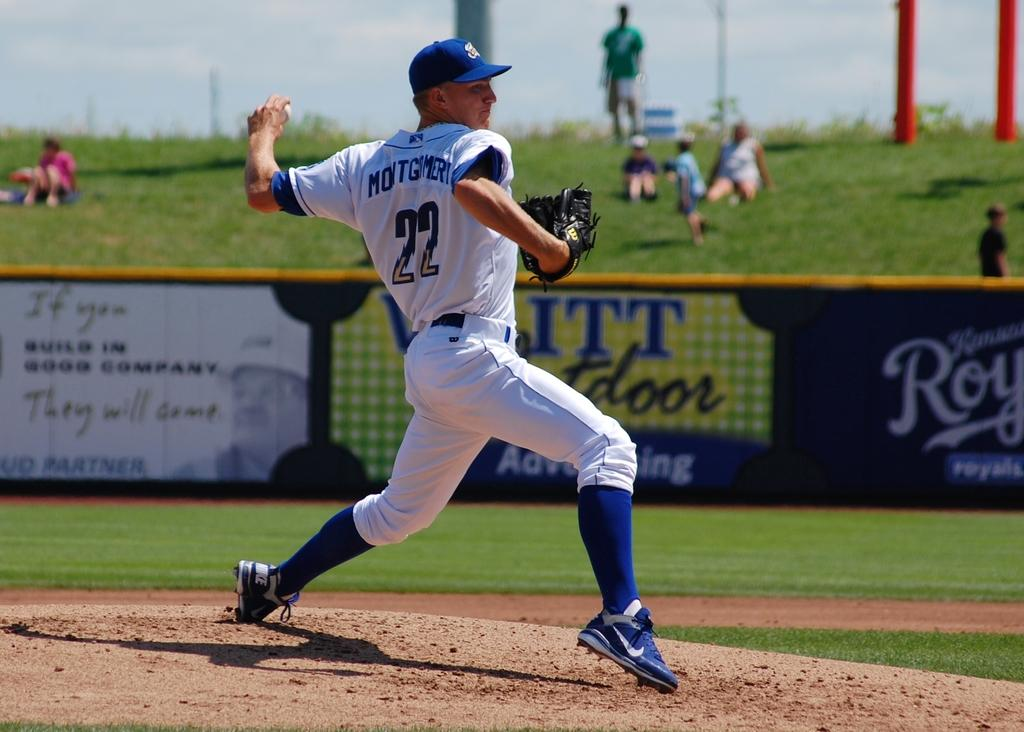Provide a one-sentence caption for the provided image. A baseball player, wearing the number 22, gets ready to throw the ball. 